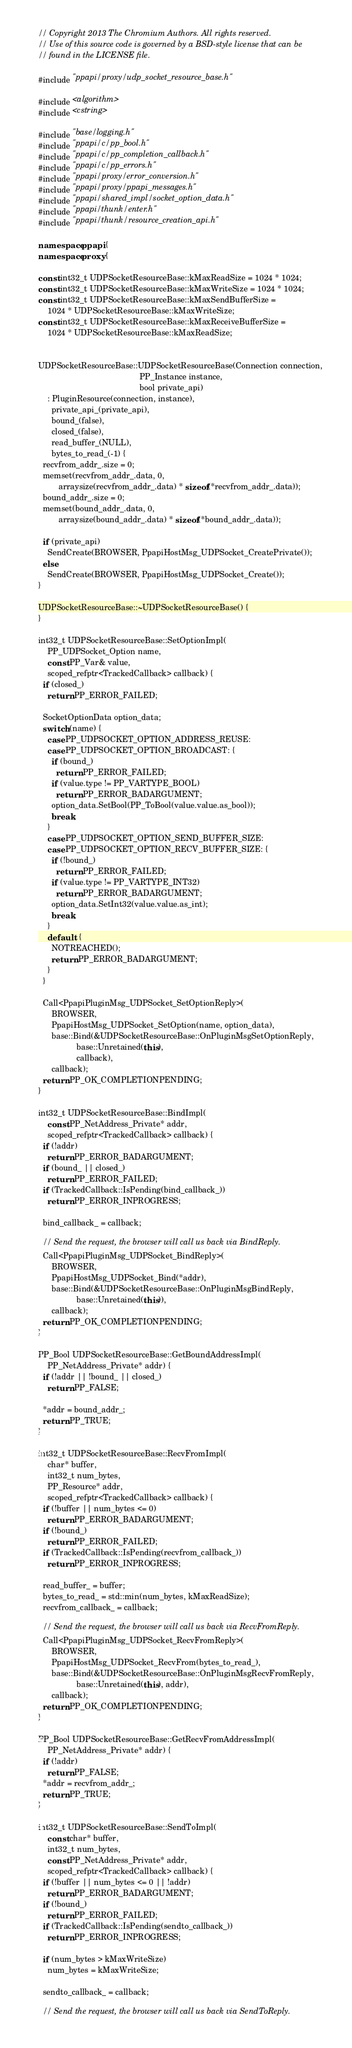Convert code to text. <code><loc_0><loc_0><loc_500><loc_500><_C++_>// Copyright 2013 The Chromium Authors. All rights reserved.
// Use of this source code is governed by a BSD-style license that can be
// found in the LICENSE file.

#include "ppapi/proxy/udp_socket_resource_base.h"

#include <algorithm>
#include <cstring>

#include "base/logging.h"
#include "ppapi/c/pp_bool.h"
#include "ppapi/c/pp_completion_callback.h"
#include "ppapi/c/pp_errors.h"
#include "ppapi/proxy/error_conversion.h"
#include "ppapi/proxy/ppapi_messages.h"
#include "ppapi/shared_impl/socket_option_data.h"
#include "ppapi/thunk/enter.h"
#include "ppapi/thunk/resource_creation_api.h"

namespace ppapi {
namespace proxy {

const int32_t UDPSocketResourceBase::kMaxReadSize = 1024 * 1024;
const int32_t UDPSocketResourceBase::kMaxWriteSize = 1024 * 1024;
const int32_t UDPSocketResourceBase::kMaxSendBufferSize =
    1024 * UDPSocketResourceBase::kMaxWriteSize;
const int32_t UDPSocketResourceBase::kMaxReceiveBufferSize =
    1024 * UDPSocketResourceBase::kMaxReadSize;


UDPSocketResourceBase::UDPSocketResourceBase(Connection connection,
                                             PP_Instance instance,
                                             bool private_api)
    : PluginResource(connection, instance),
      private_api_(private_api),
      bound_(false),
      closed_(false),
      read_buffer_(NULL),
      bytes_to_read_(-1) {
  recvfrom_addr_.size = 0;
  memset(recvfrom_addr_.data, 0,
         arraysize(recvfrom_addr_.data) * sizeof(*recvfrom_addr_.data));
  bound_addr_.size = 0;
  memset(bound_addr_.data, 0,
         arraysize(bound_addr_.data) * sizeof(*bound_addr_.data));

  if (private_api)
    SendCreate(BROWSER, PpapiHostMsg_UDPSocket_CreatePrivate());
  else
    SendCreate(BROWSER, PpapiHostMsg_UDPSocket_Create());
}

UDPSocketResourceBase::~UDPSocketResourceBase() {
}

int32_t UDPSocketResourceBase::SetOptionImpl(
    PP_UDPSocket_Option name,
    const PP_Var& value,
    scoped_refptr<TrackedCallback> callback) {
  if (closed_)
    return PP_ERROR_FAILED;

  SocketOptionData option_data;
  switch (name) {
    case PP_UDPSOCKET_OPTION_ADDRESS_REUSE:
    case PP_UDPSOCKET_OPTION_BROADCAST: {
      if (bound_)
        return PP_ERROR_FAILED;
      if (value.type != PP_VARTYPE_BOOL)
        return PP_ERROR_BADARGUMENT;
      option_data.SetBool(PP_ToBool(value.value.as_bool));
      break;
    }
    case PP_UDPSOCKET_OPTION_SEND_BUFFER_SIZE:
    case PP_UDPSOCKET_OPTION_RECV_BUFFER_SIZE: {
      if (!bound_)
        return PP_ERROR_FAILED;
      if (value.type != PP_VARTYPE_INT32)
        return PP_ERROR_BADARGUMENT;
      option_data.SetInt32(value.value.as_int);
      break;
    }
    default: {
      NOTREACHED();
      return PP_ERROR_BADARGUMENT;
    }
  }

  Call<PpapiPluginMsg_UDPSocket_SetOptionReply>(
      BROWSER,
      PpapiHostMsg_UDPSocket_SetOption(name, option_data),
      base::Bind(&UDPSocketResourceBase::OnPluginMsgSetOptionReply,
                 base::Unretained(this),
                 callback),
      callback);
  return PP_OK_COMPLETIONPENDING;
}

int32_t UDPSocketResourceBase::BindImpl(
    const PP_NetAddress_Private* addr,
    scoped_refptr<TrackedCallback> callback) {
  if (!addr)
    return PP_ERROR_BADARGUMENT;
  if (bound_ || closed_)
    return PP_ERROR_FAILED;
  if (TrackedCallback::IsPending(bind_callback_))
    return PP_ERROR_INPROGRESS;

  bind_callback_ = callback;

  // Send the request, the browser will call us back via BindReply.
  Call<PpapiPluginMsg_UDPSocket_BindReply>(
      BROWSER,
      PpapiHostMsg_UDPSocket_Bind(*addr),
      base::Bind(&UDPSocketResourceBase::OnPluginMsgBindReply,
                 base::Unretained(this)),
      callback);
  return PP_OK_COMPLETIONPENDING;
}

PP_Bool UDPSocketResourceBase::GetBoundAddressImpl(
    PP_NetAddress_Private* addr) {
  if (!addr || !bound_ || closed_)
    return PP_FALSE;

  *addr = bound_addr_;
  return PP_TRUE;
}

int32_t UDPSocketResourceBase::RecvFromImpl(
    char* buffer,
    int32_t num_bytes,
    PP_Resource* addr,
    scoped_refptr<TrackedCallback> callback) {
  if (!buffer || num_bytes <= 0)
    return PP_ERROR_BADARGUMENT;
  if (!bound_)
    return PP_ERROR_FAILED;
  if (TrackedCallback::IsPending(recvfrom_callback_))
    return PP_ERROR_INPROGRESS;

  read_buffer_ = buffer;
  bytes_to_read_ = std::min(num_bytes, kMaxReadSize);
  recvfrom_callback_ = callback;

  // Send the request, the browser will call us back via RecvFromReply.
  Call<PpapiPluginMsg_UDPSocket_RecvFromReply>(
      BROWSER,
      PpapiHostMsg_UDPSocket_RecvFrom(bytes_to_read_),
      base::Bind(&UDPSocketResourceBase::OnPluginMsgRecvFromReply,
                 base::Unretained(this), addr),
      callback);
  return PP_OK_COMPLETIONPENDING;
}

PP_Bool UDPSocketResourceBase::GetRecvFromAddressImpl(
    PP_NetAddress_Private* addr) {
  if (!addr)
    return PP_FALSE;
  *addr = recvfrom_addr_;
  return PP_TRUE;
}

int32_t UDPSocketResourceBase::SendToImpl(
    const char* buffer,
    int32_t num_bytes,
    const PP_NetAddress_Private* addr,
    scoped_refptr<TrackedCallback> callback) {
  if (!buffer || num_bytes <= 0 || !addr)
    return PP_ERROR_BADARGUMENT;
  if (!bound_)
    return PP_ERROR_FAILED;
  if (TrackedCallback::IsPending(sendto_callback_))
    return PP_ERROR_INPROGRESS;

  if (num_bytes > kMaxWriteSize)
    num_bytes = kMaxWriteSize;

  sendto_callback_ = callback;

  // Send the request, the browser will call us back via SendToReply.</code> 